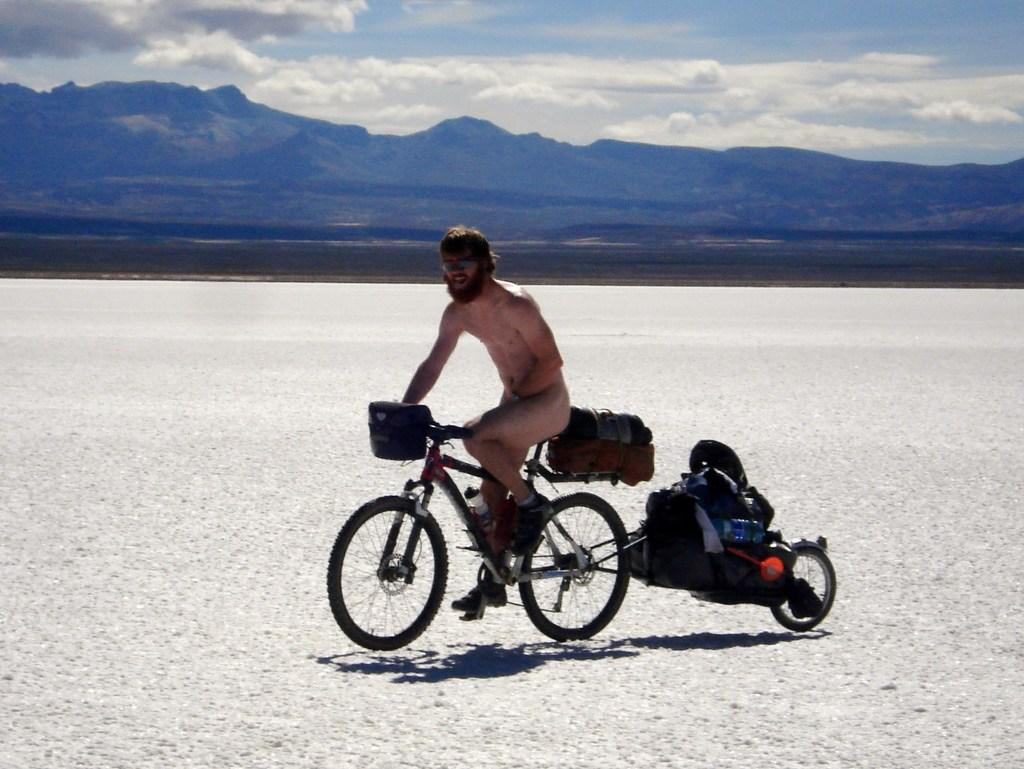What is the main subject of the image? There is a person in the image. What is the person doing in the image? The person is riding a bicycle. What is attached to the bicycle in the image? The person has luggage behind them. What type of landscape can be seen in the image? There are mountains in the image. What part of the natural environment is visible in the image? The sky is visible in the image. What type of education can be seen being provided in the image? There is no indication of education being provided in the image; it features a person riding a bicycle with luggage and a mountainous landscape. How does the person play with the mountains in the image? The person is not playing with the mountains in the image; they are riding a bicycle with luggage. 